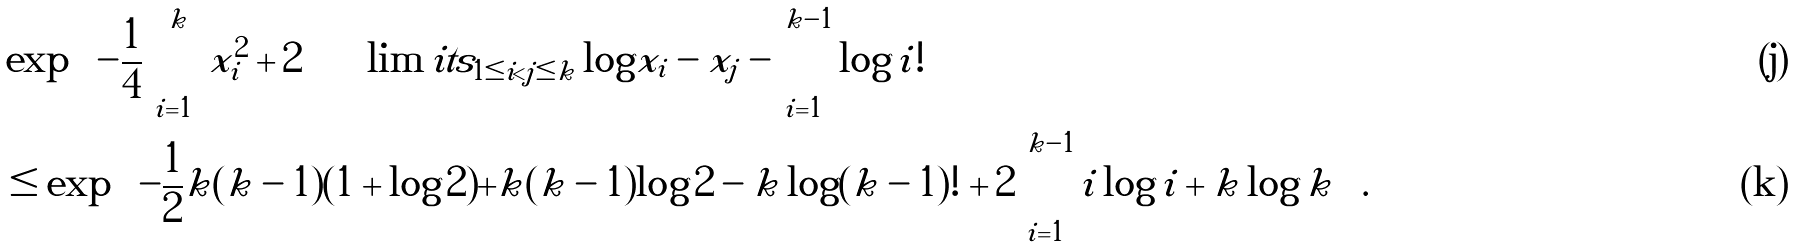<formula> <loc_0><loc_0><loc_500><loc_500>& \exp \left ( - \frac { 1 } { 4 } \sum _ { i = 1 } ^ { k } x _ { i } ^ { 2 } + 2 \sum \lim i t s _ { 1 \leq i < j \leq k } \log | x _ { i } - x _ { j } | - \sum _ { i = 1 } ^ { k - 1 } \log i ! \right ) \\ & \leq \exp \left ( - \frac { 1 } { 2 } k ( k - 1 ) ( 1 + \log 2 ) + k ( k - 1 ) \log 2 - k \log ( k - 1 ) ! + 2 \sum _ { i = 1 } ^ { k - 1 } i \log i + k \log k \right ) .</formula> 